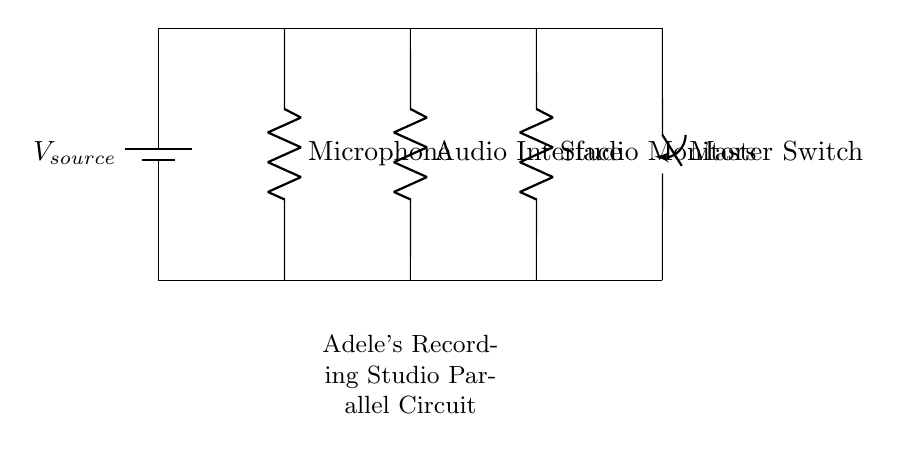What is the type of circuit shown? The circuit is a parallel circuit, as indicated by the multiple components connected across the same voltage source. Each device has its own separate path to the source.
Answer: Parallel How many devices are connected in this circuit? There are three devices connected in the circuit; a microphone, an audio interface, and studio monitors, each drawn separately in parallel.
Answer: Three What is the function of the master switch? The master switch allows the user to control the entire circuit, enabling or disabling the power to all connected devices simultaneously.
Answer: Control Which device is used for audio output? The studio monitors are typically used for audio output in a recording studio, as they play back sound from the audio interface.
Answer: Studio Monitors What happens if one device fails in this circuit? If one device fails, the other devices continue to operate normally, as each device is on a separate branch of the parallel circuit.
Answer: Continue operating What is the role of the battery in this circuit? The battery serves as the voltage source for the parallel circuit, providing the necessary voltage to power all the connected devices.
Answer: Voltage source 